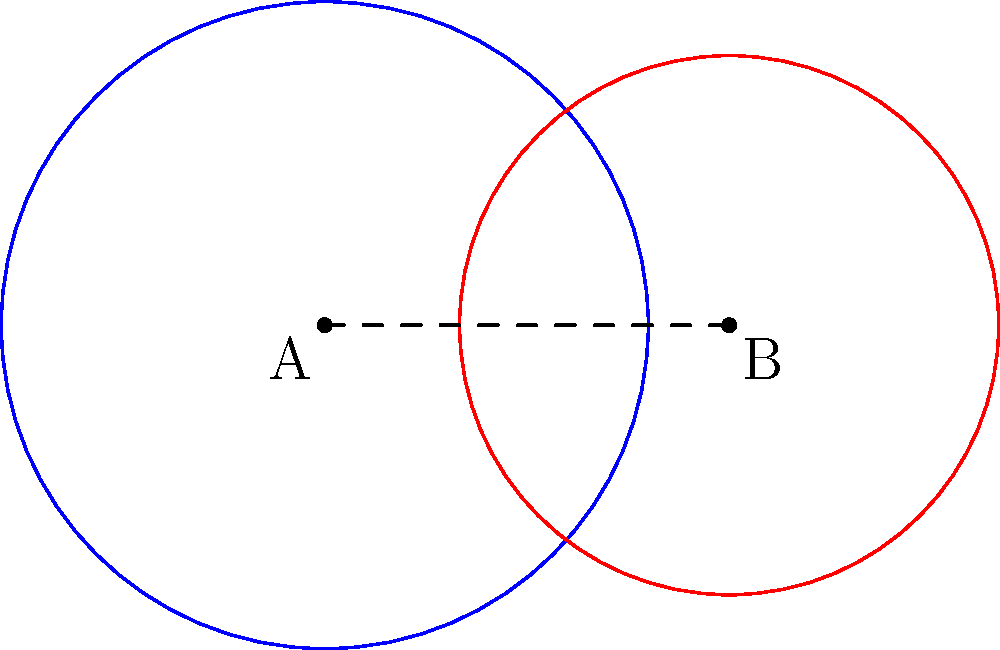Two circular regions represent the effects of different hormone therapies. Circle A, centered at (0,0) with radius 1.2, represents therapy A. Circle B, centered at (1.5,0) with radius 1, represents therapy B. Calculate the area of the intersection between these two therapies, representing their combined effect. Round your answer to two decimal places. To find the area of intersection between two circles, we'll follow these steps:

1) First, calculate the distance between the centers:
   $d = 1.5$ (given in the coordinate of circle B's center)

2) The radii are: $r_1 = 1.2$ and $r_2 = 1$

3) Check if the circles intersect:
   $r_1 + r_2 > d > |r_1 - r_2|$
   $2.2 > 1.5 > 0.2$, so they do intersect.

4) Calculate the angles $\theta_1$ and $\theta_2$:
   $\cos(\theta_1) = \frac{r_1^2 + d^2 - r_2^2}{2r_1d} = \frac{1.2^2 + 1.5^2 - 1^2}{2(1.2)(1.5)} = 0.7292$
   $\theta_1 = \arccos(0.7292) = 0.7540$ radians

   $\cos(\theta_2) = \frac{r_2^2 + d^2 - r_1^2}{2r_2d} = \frac{1^2 + 1.5^2 - 1.2^2}{2(1)(1.5)} = 0.7000$
   $\theta_2 = \arccos(0.7000) = 0.7954$ radians

5) Calculate the area of intersection:
   $A = r_1^2 \cdot \theta_1 + r_2^2 \cdot \theta_2 - \frac{1}{2}[r_1^2 \sin(2\theta_1) + r_2^2 \sin(2\theta_2)]$
   $A = 1.2^2 \cdot 0.7540 + 1^2 \cdot 0.7954 - \frac{1}{2}[1.2^2 \sin(2 \cdot 0.7540) + 1^2 \sin(2 \cdot 0.7954)]$
   $A = 1.0858 + 0.7954 - 0.5(1.0780 + 0.7492) = 0.9747$

6) Rounding to two decimal places: 0.97 square units.
Answer: 0.97 square units 